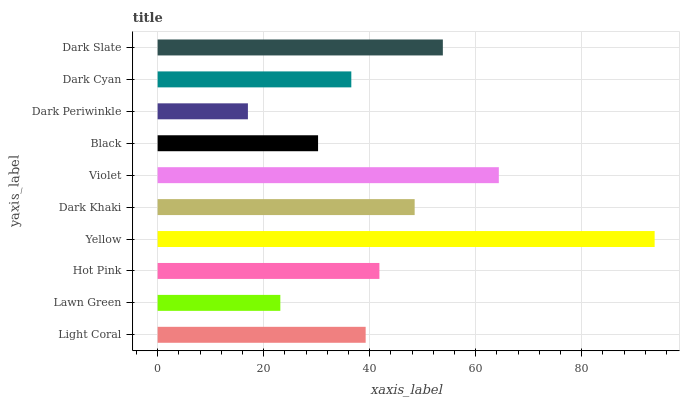Is Dark Periwinkle the minimum?
Answer yes or no. Yes. Is Yellow the maximum?
Answer yes or no. Yes. Is Lawn Green the minimum?
Answer yes or no. No. Is Lawn Green the maximum?
Answer yes or no. No. Is Light Coral greater than Lawn Green?
Answer yes or no. Yes. Is Lawn Green less than Light Coral?
Answer yes or no. Yes. Is Lawn Green greater than Light Coral?
Answer yes or no. No. Is Light Coral less than Lawn Green?
Answer yes or no. No. Is Hot Pink the high median?
Answer yes or no. Yes. Is Light Coral the low median?
Answer yes or no. Yes. Is Dark Slate the high median?
Answer yes or no. No. Is Dark Periwinkle the low median?
Answer yes or no. No. 